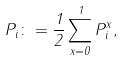<formula> <loc_0><loc_0><loc_500><loc_500>P _ { i } \colon = \frac { 1 } { 2 } \sum _ { x = 0 } ^ { 1 } P _ { i } ^ { x } ,</formula> 